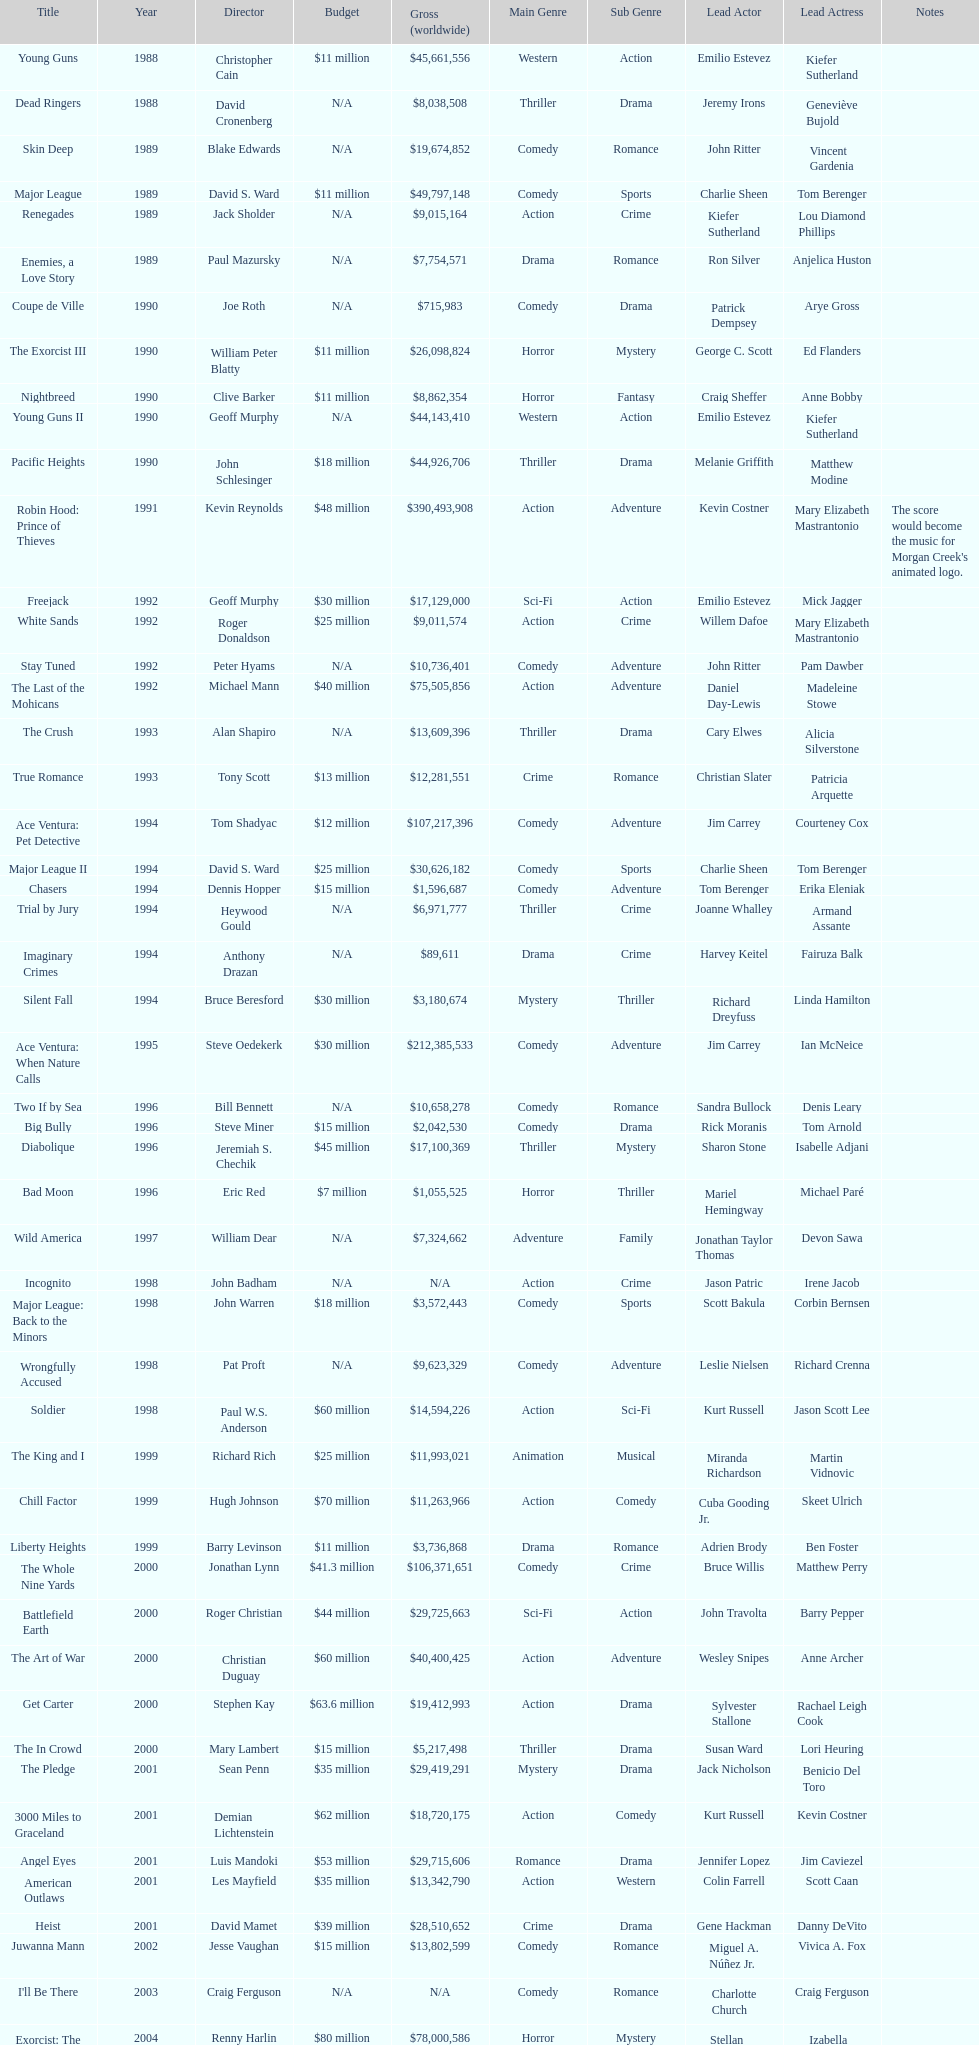What movie came out after bad moon? Wild America. 